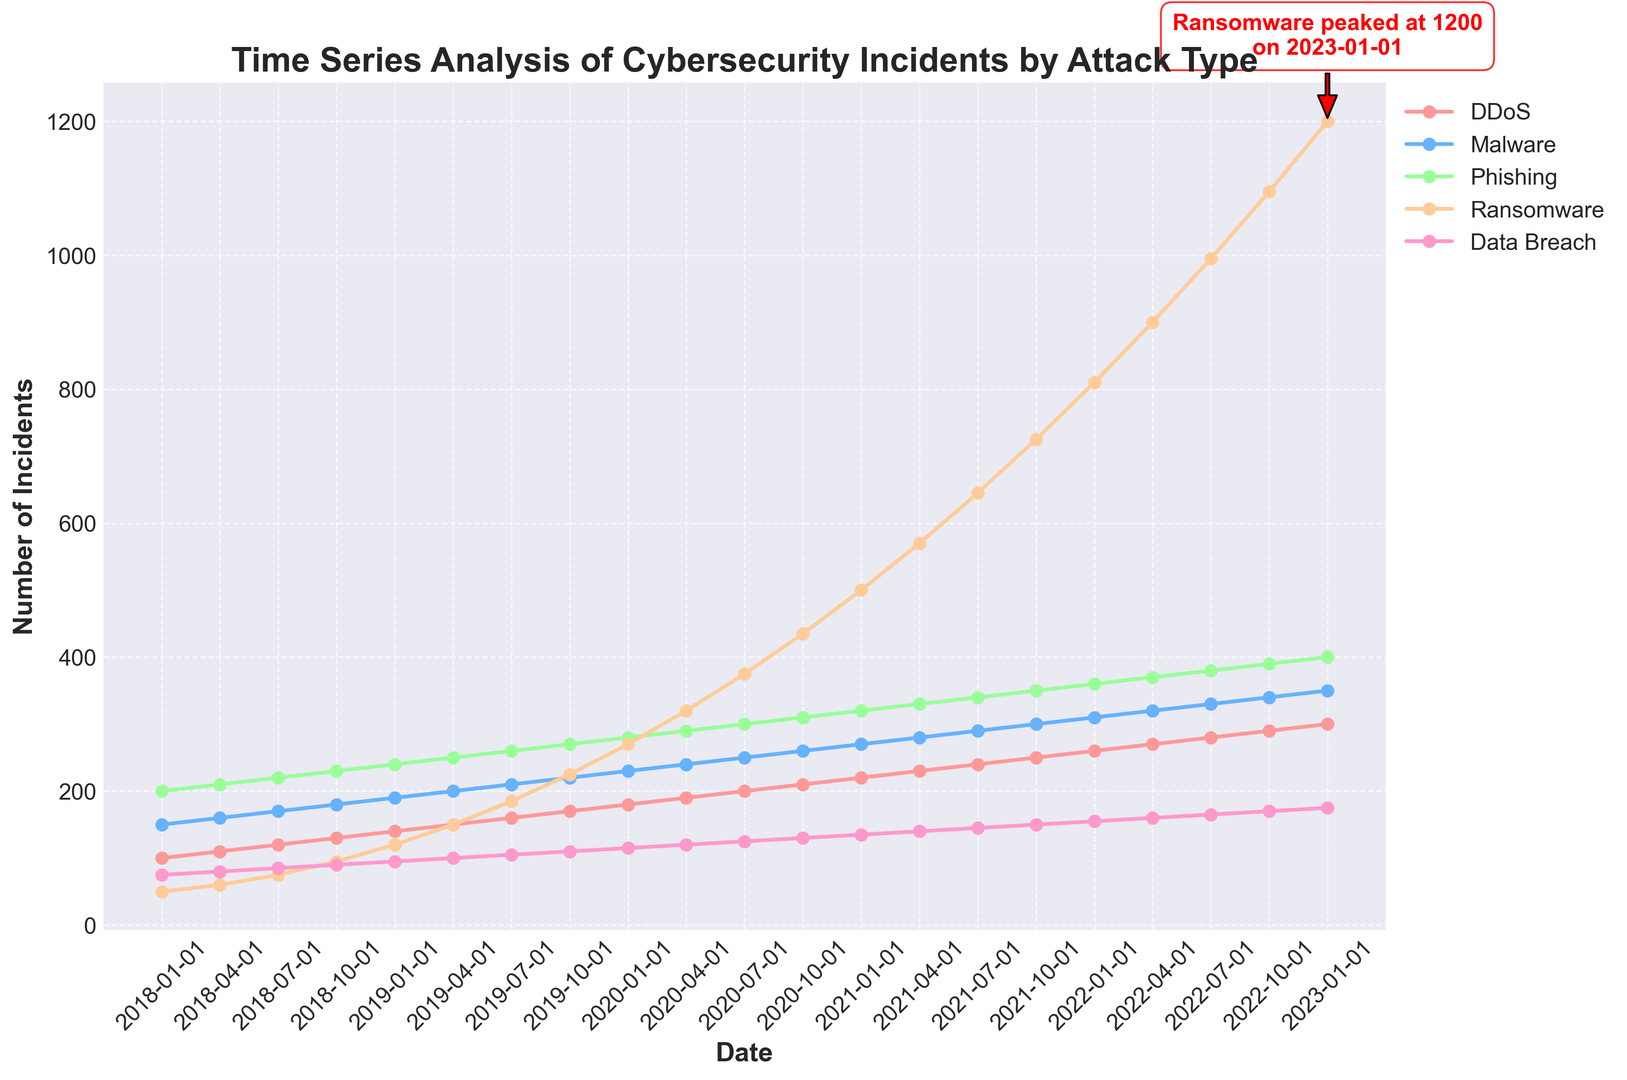What is the value of the Ransomware incidents when it peaked? The annotation on the chart points out that the Ransomware incidents peaked at a certain point. According to the annotation, Ransomware peaked at 1200 incidents.
Answer: 1200 Which attack type has shown a consistent increase over the years and is highlighted in the annotation? The annotation specifically calls out Ransomware by mentioning its peak value and gives a visual indication through an arrow. Ransomware shows a clear and rapid increase over the years, reaching its highest peak.
Answer: Ransomware Compare the trend of Malware and Phishing incidents. Which one had a higher number of incidents by the end of the period? By looking at the ending points of the two lines representing Malware and Phishing, we can see that both lines are upward-sloping. However, the line for Phishing (which reaches 400 incidents) is higher than that for Malware (which reaches 350 incidents).
Answer: Phishing What is the general trend of Data Breach incidents from 2018 to 2023? Observing the Data Breach line, it starts at a lower value in 2018 and consistently trends upward throughout the period. By January 2023, it reaches 175 incidents.
Answer: Increasing By how much did DDoS incidents increase from January 2018 to January 2023? DDoS incidents started at 100 in January 2018 and ended at 300 in January 2023. The increase is calculated by subtracting the initial value from the final value: 300 - 100 = 200.
Answer: 200 During which time period did the Ransomware incidents see the most significant increase? By observing the steepness of the Ransomware line, the most significant increase seems to occur between 2020 and 2021, where there is a sharp upward movement reaching from 270 to 500 and beyond.
Answer: 2020-2021 Which attack type had the least number of incidents at the start of the time series? At the beginning of the time series (January 2018), the values can be compared. The attack type with the lowest value is Ransomware with 50 incidents.
Answer: Ransomware What is the difference in the number of Data Breach incidents between the first and the last data points? Data Breach started with 75 incidents in January 2018 and ended with 175 incidents in January 2023. The difference is calculated as 175 - 75 = 100.
Answer: 100 Summarize the relative positions of Ransomware incidents in mid-2020 and end-2022. Which one is higher? By comparing the points around mid-2020 (July 2020, 375 incidents) and end-2022 (October 2022, 1095 incidents), it's clear that the number of incidents for Ransomware at the end of 2022 is higher.
Answer: End-2022 